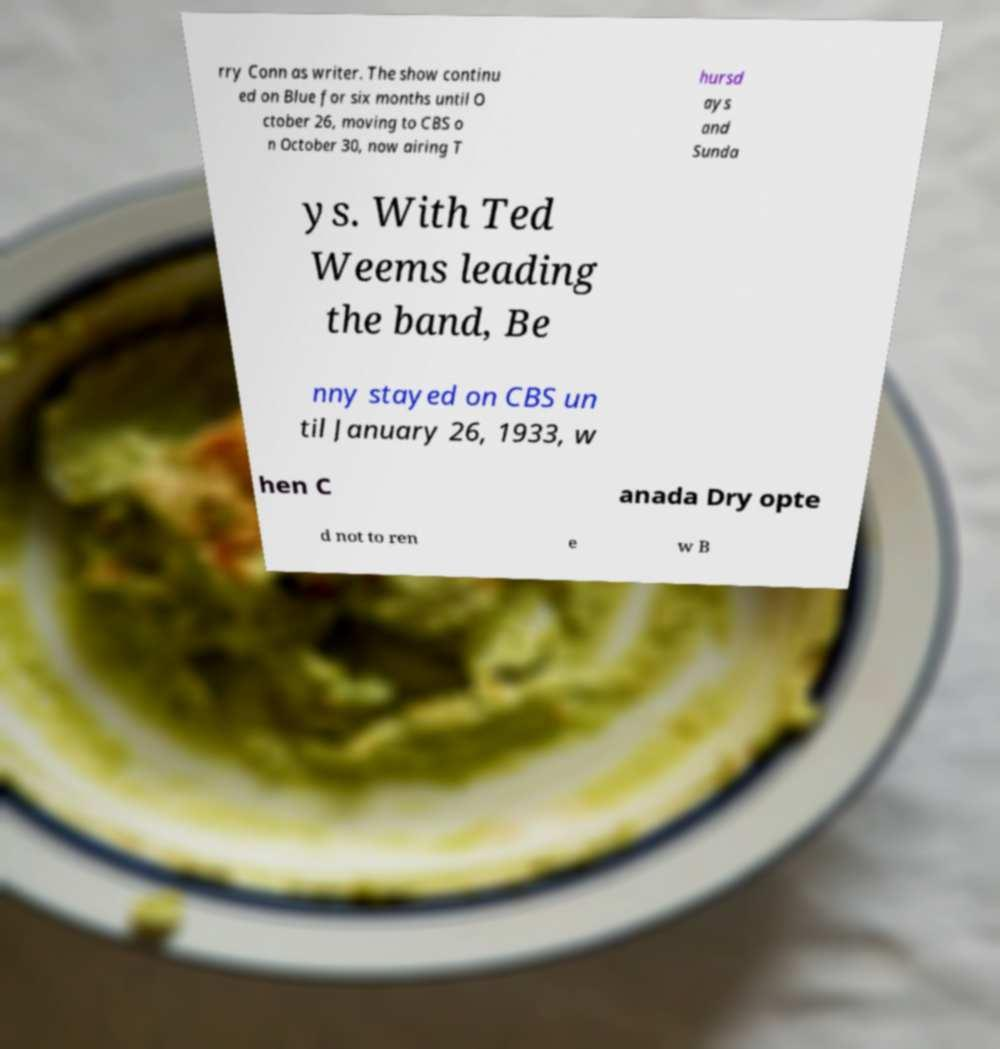Could you assist in decoding the text presented in this image and type it out clearly? rry Conn as writer. The show continu ed on Blue for six months until O ctober 26, moving to CBS o n October 30, now airing T hursd ays and Sunda ys. With Ted Weems leading the band, Be nny stayed on CBS un til January 26, 1933, w hen C anada Dry opte d not to ren e w B 